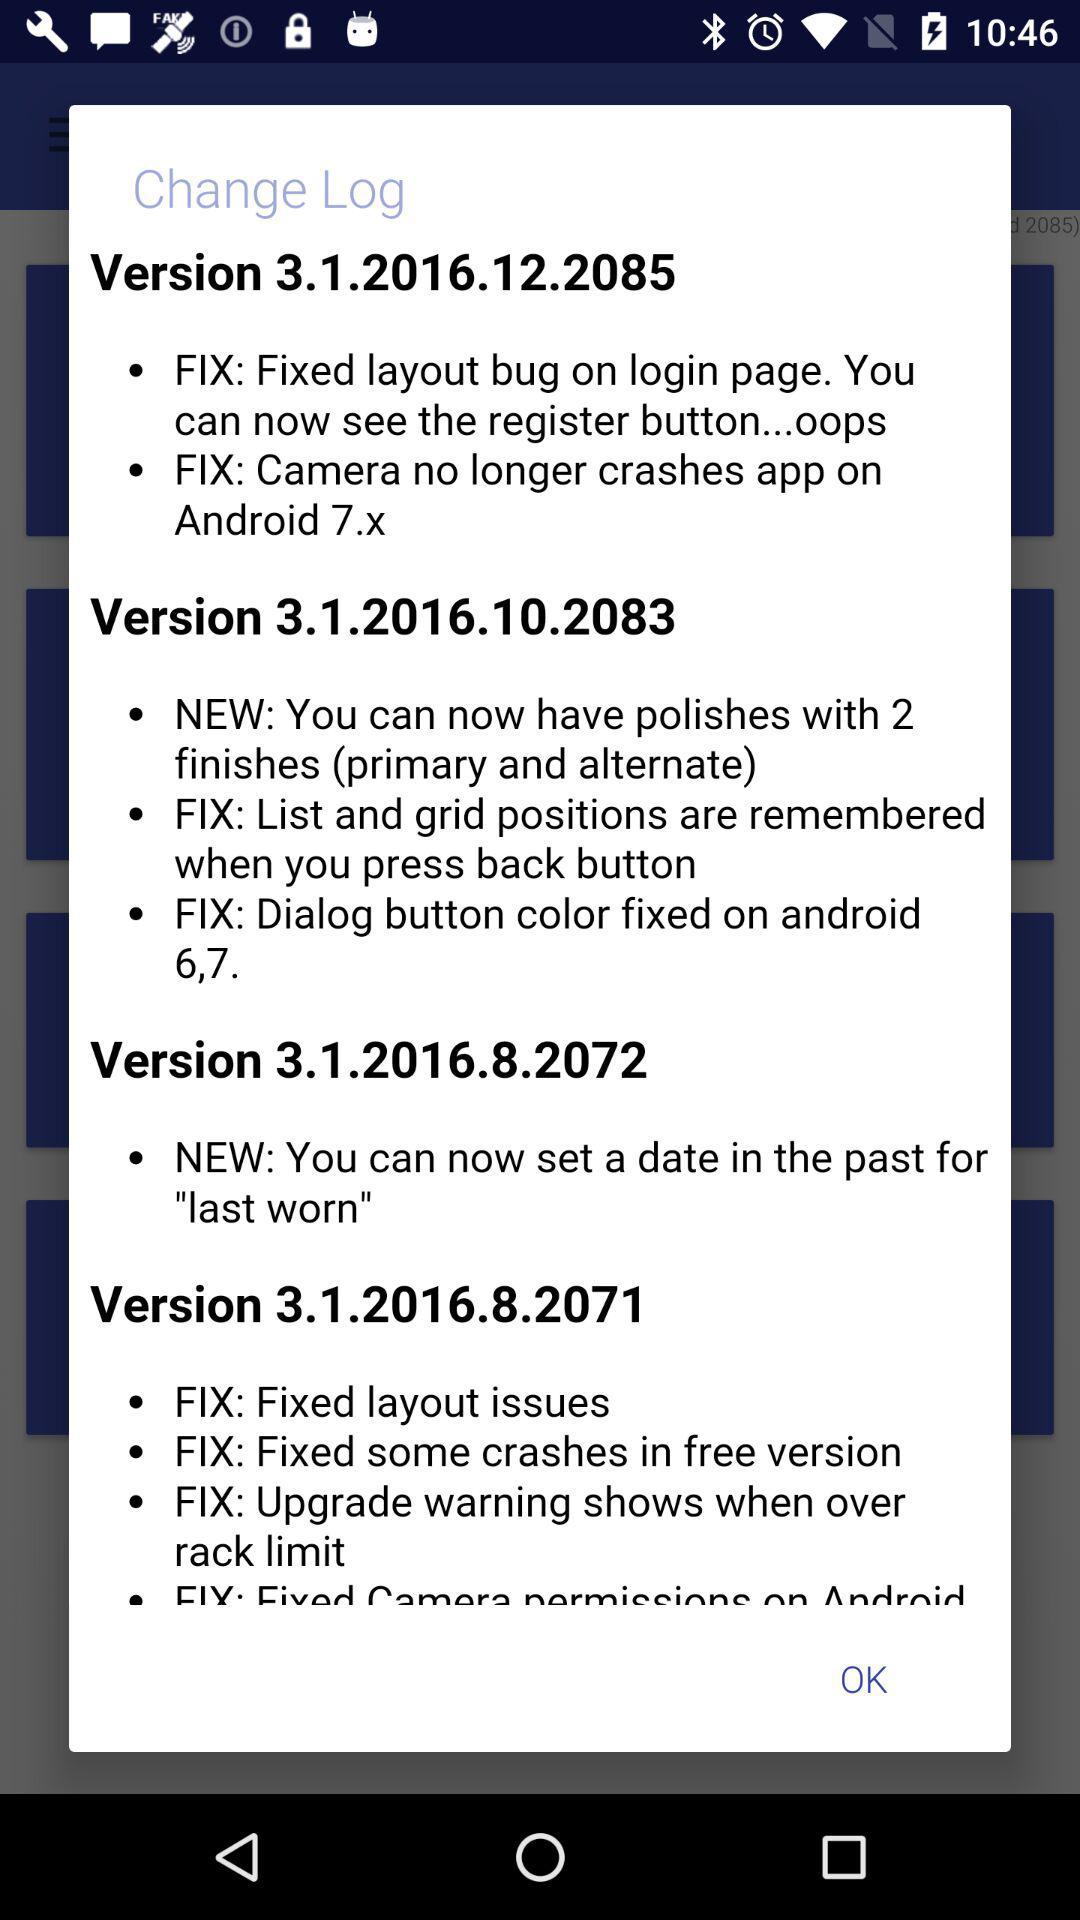What are the new fixes in version 3.1.2016.12.2085? The new fixes are "Fixed layout bug on login page. You can now see the register button...oops" and "Camera no longer crashes app on Android 7.x". 